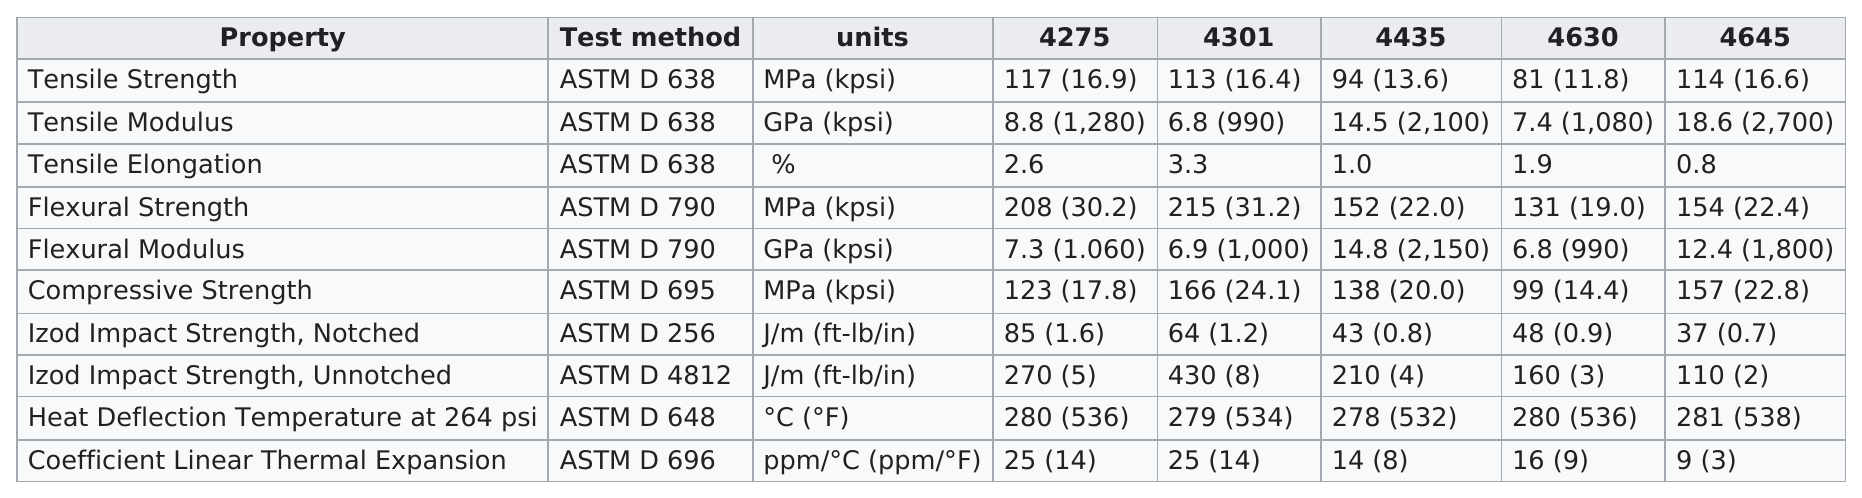Identify some key points in this picture. The grade of steel that has a flexural strength above 210 is 4301. The test method for tensile strength was the same as the test method for tensile elongation, and the answer was yes. Flexural modulus is the property listed after flexural strength in the measurement of the ability of a material to withstand bending stress. According to the information provided, ASTM D 638 is listed as the test method three times. There are more properties than 8. 